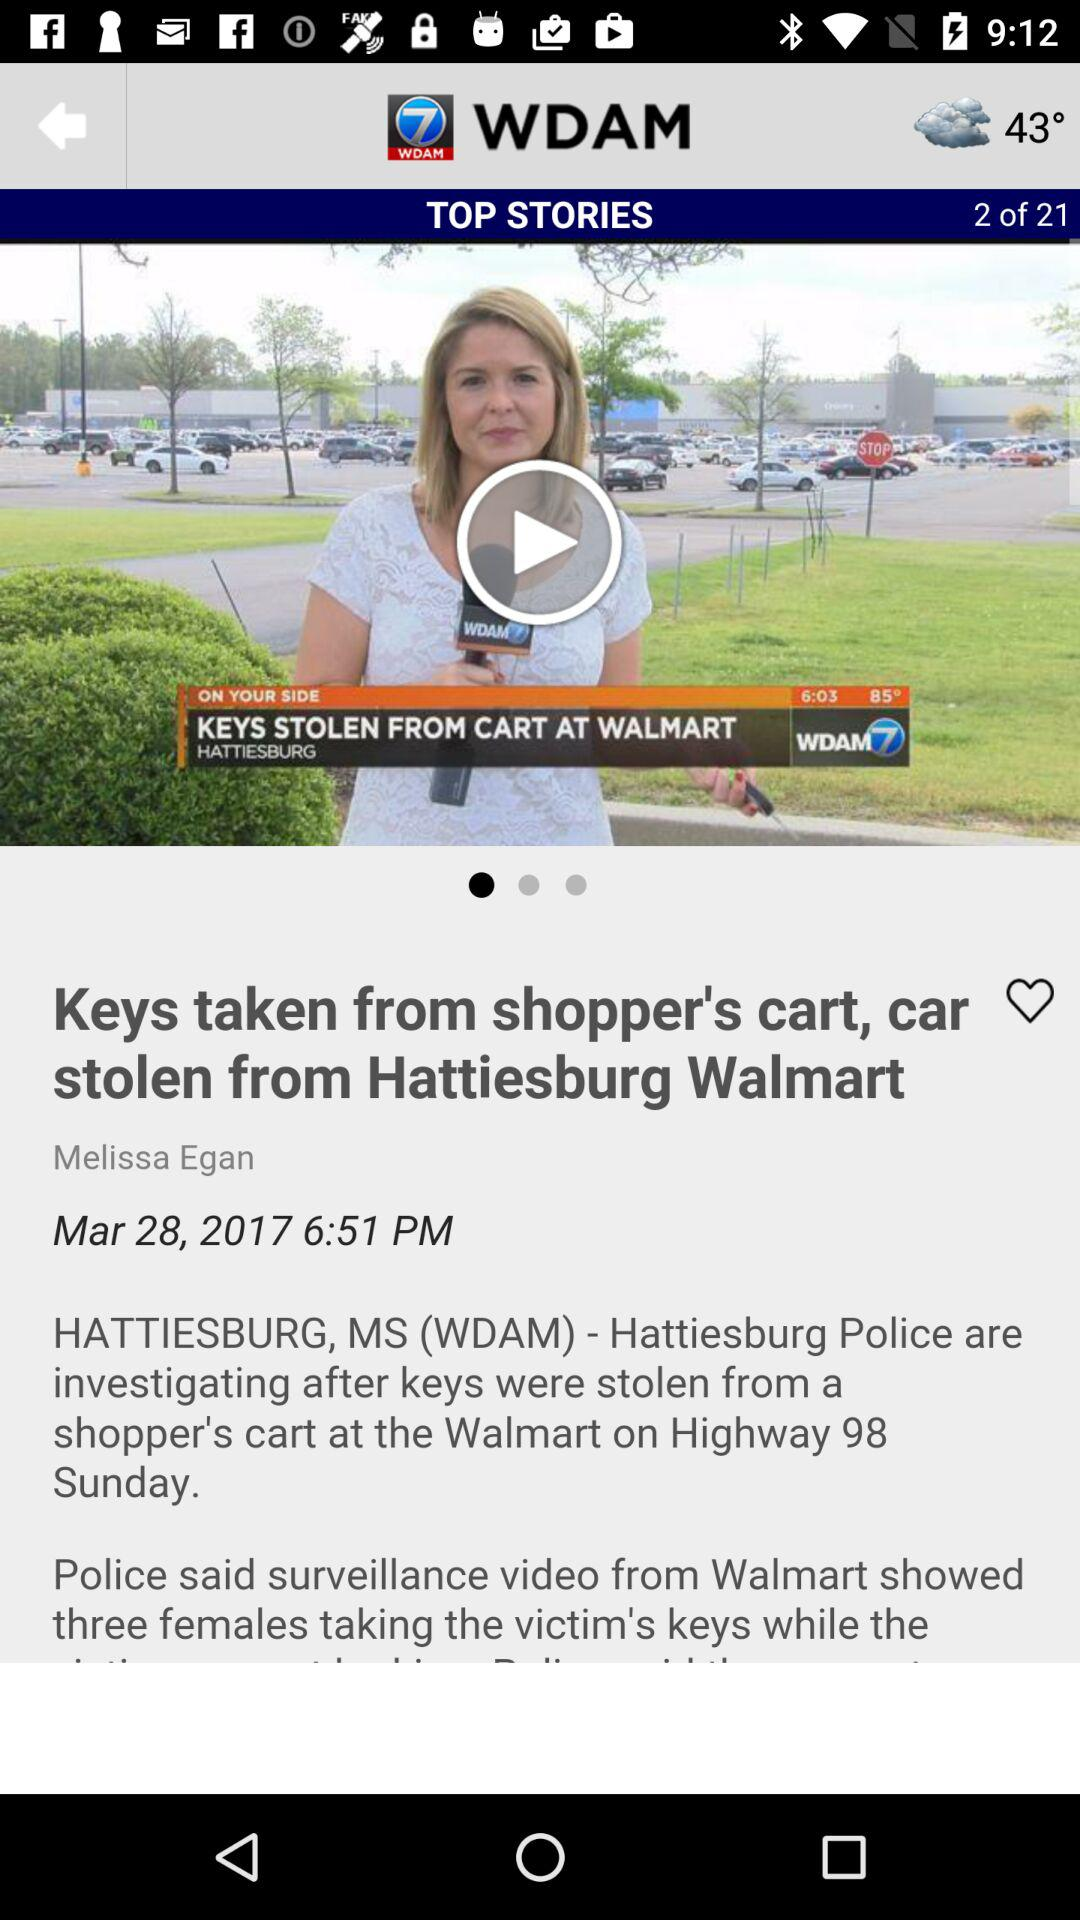When was the news posted? The news was posted on March 28, 2017 at 6:51 PM. 